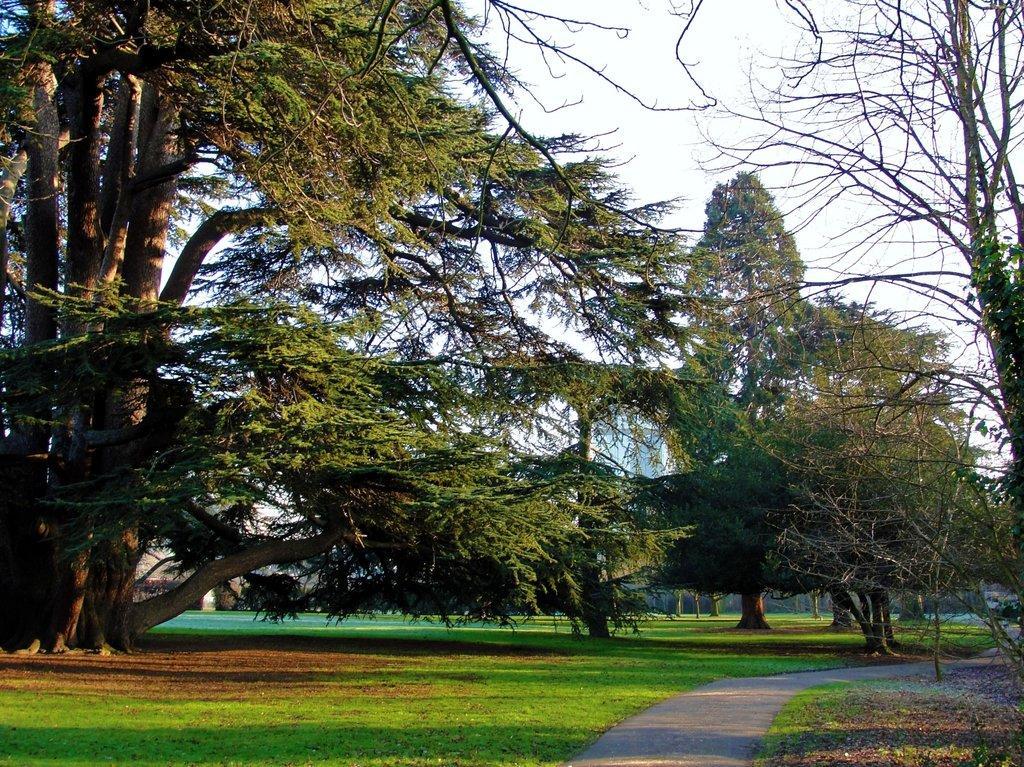Could you give a brief overview of what you see in this image? In this image we can see buildings, trees, ground, road and sky. 